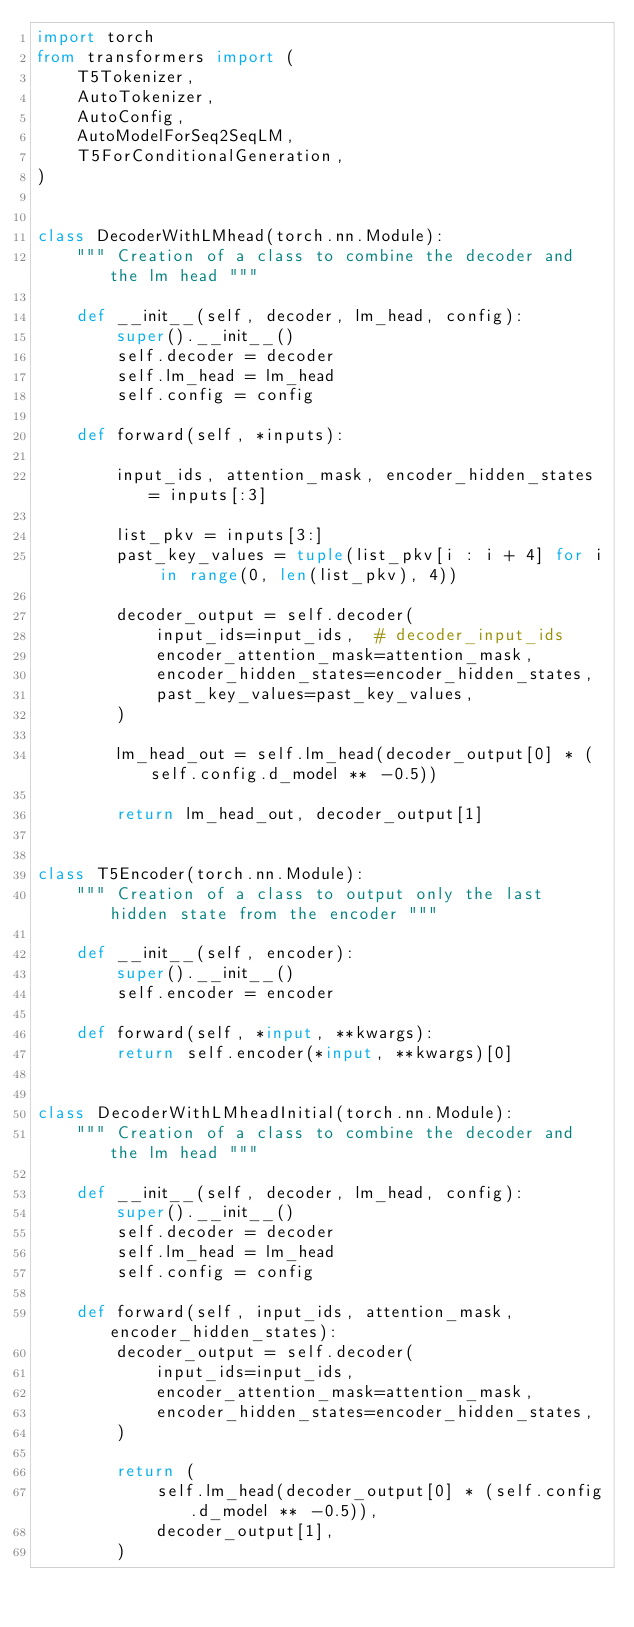<code> <loc_0><loc_0><loc_500><loc_500><_Python_>import torch
from transformers import (
    T5Tokenizer,
    AutoTokenizer,
    AutoConfig,
    AutoModelForSeq2SeqLM,
    T5ForConditionalGeneration,
)


class DecoderWithLMhead(torch.nn.Module):
    """ Creation of a class to combine the decoder and the lm head """

    def __init__(self, decoder, lm_head, config):
        super().__init__()
        self.decoder = decoder
        self.lm_head = lm_head
        self.config = config

    def forward(self, *inputs):

        input_ids, attention_mask, encoder_hidden_states = inputs[:3]

        list_pkv = inputs[3:]
        past_key_values = tuple(list_pkv[i : i + 4] for i in range(0, len(list_pkv), 4))

        decoder_output = self.decoder(
            input_ids=input_ids,  # decoder_input_ids
            encoder_attention_mask=attention_mask,
            encoder_hidden_states=encoder_hidden_states,
            past_key_values=past_key_values,
        )

        lm_head_out = self.lm_head(decoder_output[0] * (self.config.d_model ** -0.5))

        return lm_head_out, decoder_output[1]


class T5Encoder(torch.nn.Module):
    """ Creation of a class to output only the last hidden state from the encoder """

    def __init__(self, encoder):
        super().__init__()
        self.encoder = encoder

    def forward(self, *input, **kwargs):
        return self.encoder(*input, **kwargs)[0]


class DecoderWithLMheadInitial(torch.nn.Module):
    """ Creation of a class to combine the decoder and the lm head """

    def __init__(self, decoder, lm_head, config):
        super().__init__()
        self.decoder = decoder
        self.lm_head = lm_head
        self.config = config

    def forward(self, input_ids, attention_mask, encoder_hidden_states):
        decoder_output = self.decoder(
            input_ids=input_ids,
            encoder_attention_mask=attention_mask,
            encoder_hidden_states=encoder_hidden_states,
        )

        return (
            self.lm_head(decoder_output[0] * (self.config.d_model ** -0.5)),
            decoder_output[1],
        )
</code> 